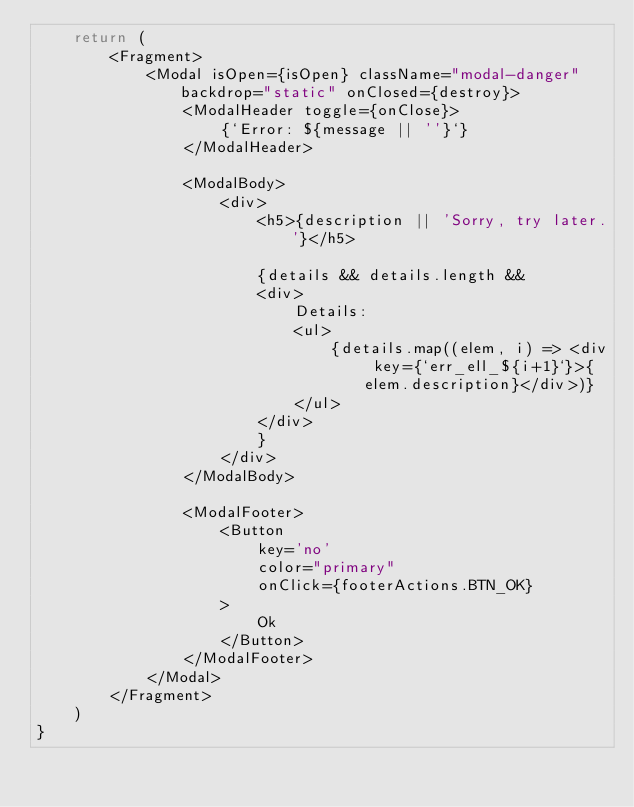Convert code to text. <code><loc_0><loc_0><loc_500><loc_500><_JavaScript_>    return (
        <Fragment>
            <Modal isOpen={isOpen} className="modal-danger" backdrop="static" onClosed={destroy}>
                <ModalHeader toggle={onClose}>
                    {`Error: ${message || ''}`}
                </ModalHeader>

                <ModalBody>
                    <div>
                        <h5>{description || 'Sorry, try later.'}</h5>

                        {details && details.length &&
                        <div>
                            Details:
                            <ul>
                                {details.map((elem, i) => <div key={`err_ell_${i+1}`}>{elem.description}</div>)}
                            </ul>
                        </div>
                        }
                    </div>
                </ModalBody>

                <ModalFooter>
                    <Button
                        key='no'
                        color="primary"
                        onClick={footerActions.BTN_OK}
                    >
                        Ok
                    </Button>
                </ModalFooter>
            </Modal>
        </Fragment>
    )
}

</code> 